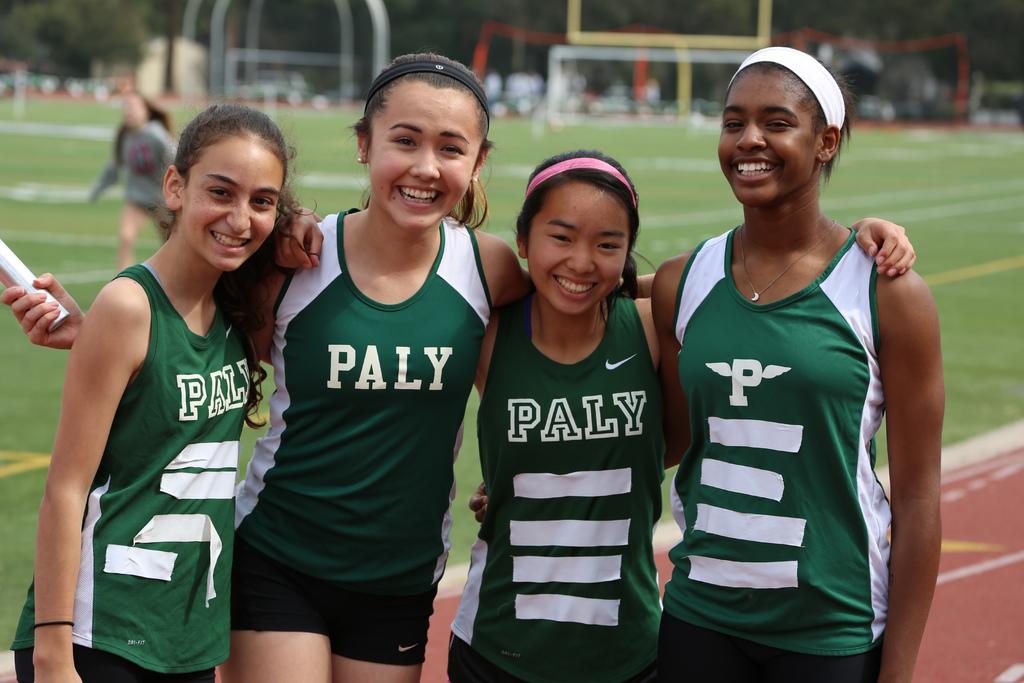What team are they on?
Give a very brief answer. Paly. 